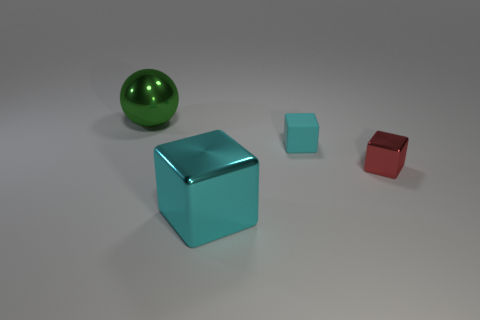Subtract all gray cylinders. How many cyan cubes are left? 2 Add 1 tiny red metallic things. How many objects exist? 5 Subtract all small blocks. How many blocks are left? 1 Subtract all blue cubes. Subtract all gray cylinders. How many cubes are left? 3 Subtract all big shiny things. Subtract all cyan rubber cylinders. How many objects are left? 2 Add 4 large balls. How many large balls are left? 5 Add 3 cyan matte objects. How many cyan matte objects exist? 4 Subtract 1 green spheres. How many objects are left? 3 Subtract all spheres. How many objects are left? 3 